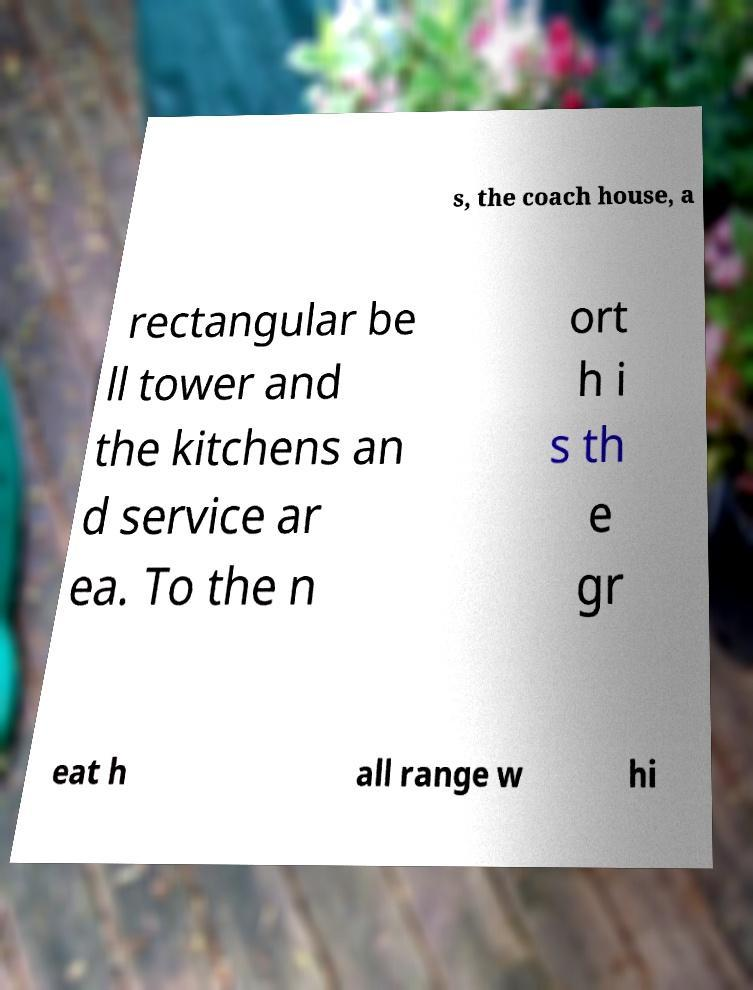Can you accurately transcribe the text from the provided image for me? s, the coach house, a rectangular be ll tower and the kitchens an d service ar ea. To the n ort h i s th e gr eat h all range w hi 